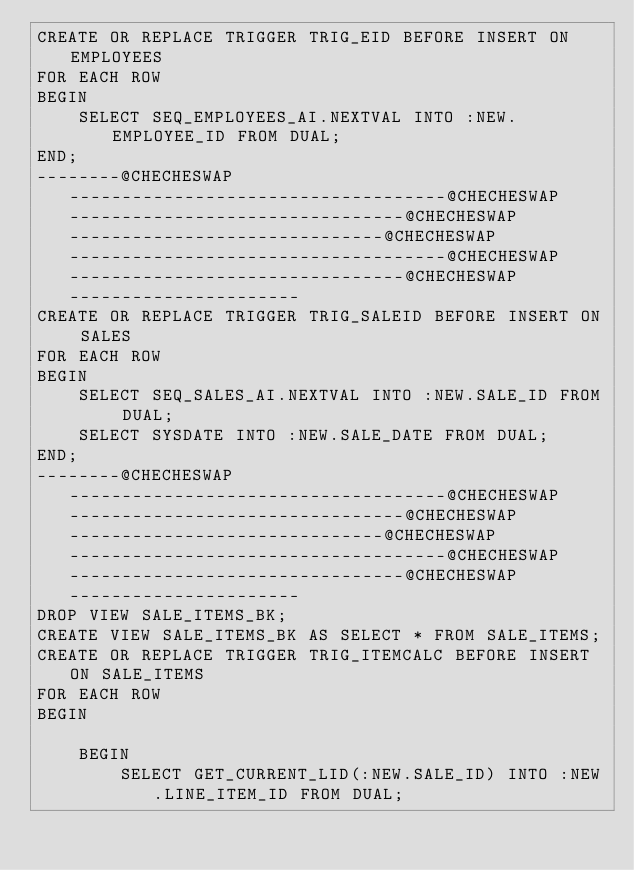Convert code to text. <code><loc_0><loc_0><loc_500><loc_500><_SQL_>CREATE OR REPLACE TRIGGER TRIG_EID BEFORE INSERT ON EMPLOYEES 
FOR EACH ROW 
BEGIN
    SELECT SEQ_EMPLOYEES_AI.NEXTVAL INTO :NEW.EMPLOYEE_ID FROM DUAL;
END;
--------@CHECHESWAP------------------------------------@CHECHESWAP--------------------------------@CHECHESWAP------------------------------@CHECHESWAP------------------------------------@CHECHESWAP--------------------------------@CHECHESWAP----------------------
CREATE OR REPLACE TRIGGER TRIG_SALEID BEFORE INSERT ON SALES 
FOR EACH ROW
BEGIN
    SELECT SEQ_SALES_AI.NEXTVAL INTO :NEW.SALE_ID FROM DUAL;
    SELECT SYSDATE INTO :NEW.SALE_DATE FROM DUAL;
END;
--------@CHECHESWAP------------------------------------@CHECHESWAP--------------------------------@CHECHESWAP------------------------------@CHECHESWAP------------------------------------@CHECHESWAP--------------------------------@CHECHESWAP----------------------
DROP VIEW SALE_ITEMS_BK;
CREATE VIEW SALE_ITEMS_BK AS SELECT * FROM SALE_ITEMS;
CREATE OR REPLACE TRIGGER TRIG_ITEMCALC BEFORE INSERT ON SALE_ITEMS 
FOR EACH ROW
BEGIN

    BEGIN
        SELECT GET_CURRENT_LID(:NEW.SALE_ID) INTO :NEW.LINE_ITEM_ID FROM DUAL;</code> 